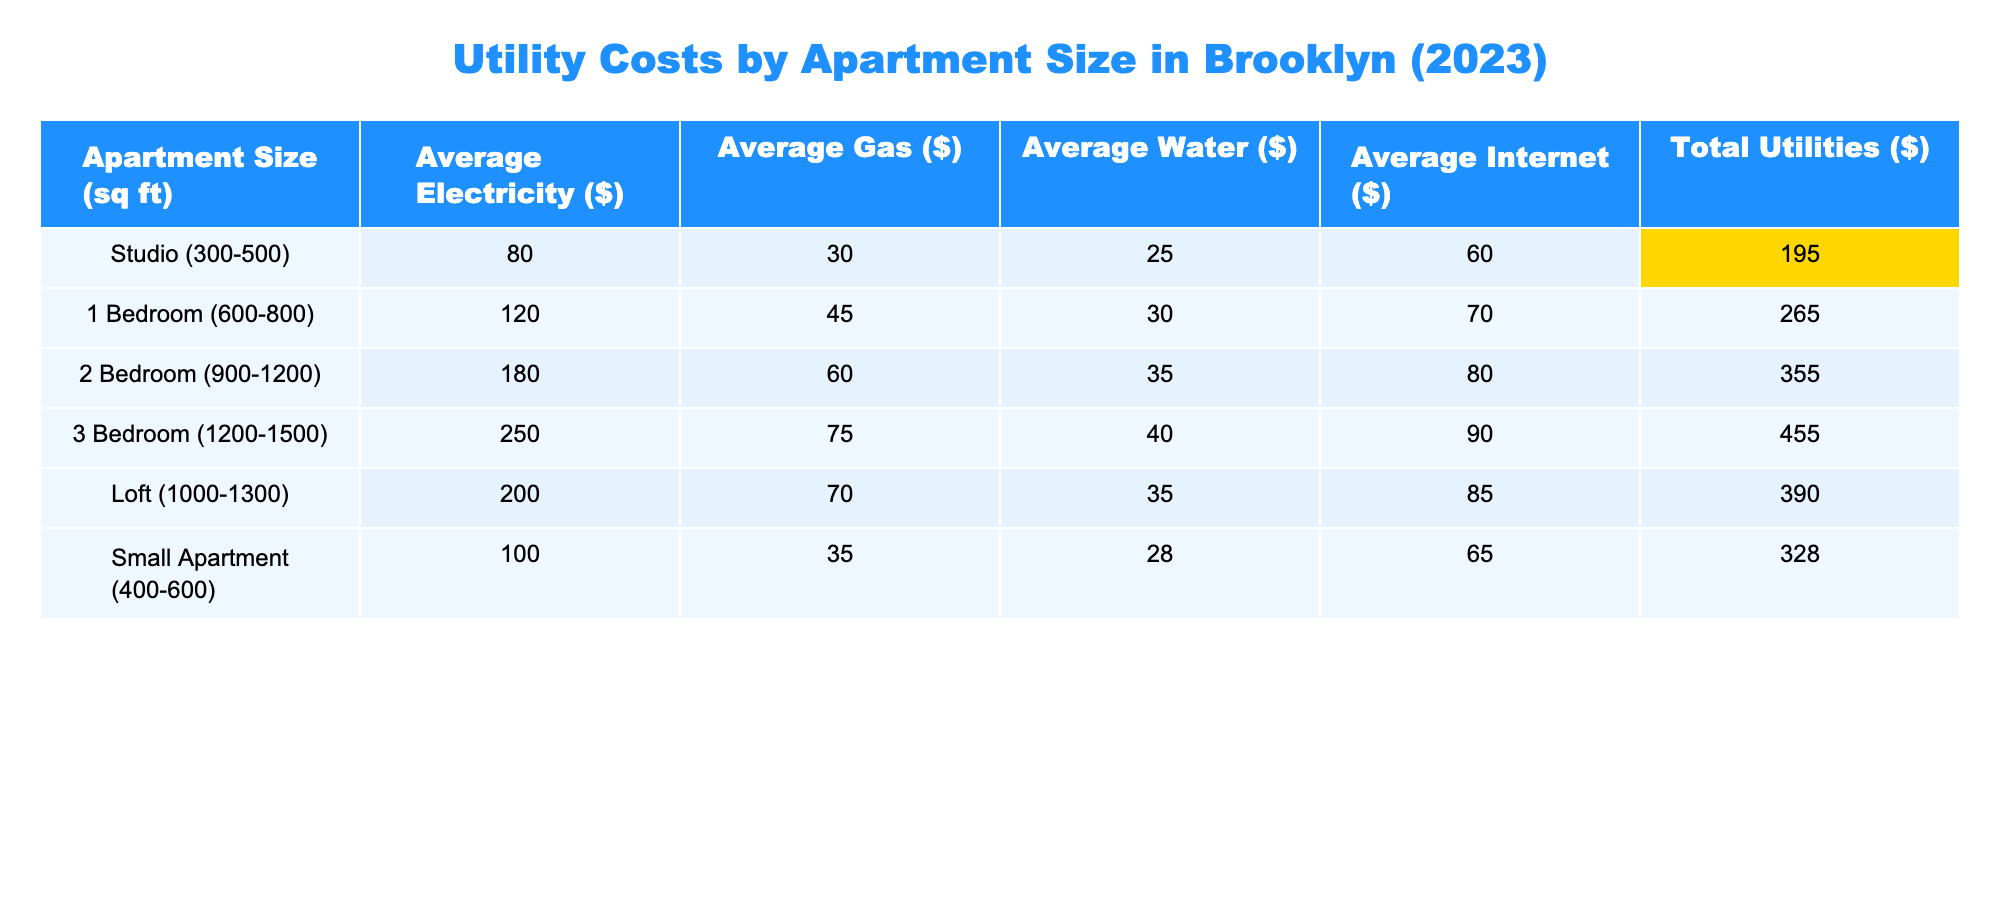What's the total utility cost for a studio apartment? The table shows the total utilities cost for a studio apartment as $195.
Answer: 195 Which apartment size has the highest average electricity cost? The 3 Bedroom apartment has the highest average electricity cost of $250.
Answer: 3 Bedroom What is the average total utilities cost for a 1 Bedroom apartment? According to the table, the average total utilities cost for a 1 Bedroom apartment is $265.
Answer: 265 Is the average internet cost for a Loft apartment greater than that for a Studio apartment? The average internet cost for a Loft apartment is $85, while for a Studio apartment, it is $60. Since $85 is greater than $60, the statement is true.
Answer: Yes What is the difference in total utilities cost between a 2 Bedroom and a 3 Bedroom apartment? The total utilities cost for a 2 Bedroom apartment is $355, and for a 3 Bedroom, it is $455. The difference is $455 - $355 = $100.
Answer: 100 What is the average gas cost for all apartment sizes? The gas costs across apartment sizes are: 30, 45, 60, 75, 70, and 35. The sum is 30 + 45 + 60 + 75 + 70 + 35 = 315. There are 6 data points, so the average is 315 / 6 = 52.5.
Answer: 52.5 Do lofts have lower average water costs than 1 Bedroom apartments? The average water cost for Loft apartments is $35, and for 1 Bedroom apartments, it is $30. Since $35 is not lower than $30, the answer is false.
Answer: No Which apartment size has the lowest total utilities cost and what is that cost? The table highlights that the Studio apartment has the lowest total utilities cost of $195.
Answer: 195 If I combine the total utilities costs of a Small Apartment and a Loft, what will be the total? The total utilities cost for a Small Apartment is $328, and for a Loft, it is $390. Adding these gives $328 + $390 = $718.
Answer: 718 Is the average water cost for a Studio apartment greater than the average for a Loft? The average water cost for the Studio apartment is $25, and for the Loft, it is $35. Since $25 is not greater than $35, the statement is false.
Answer: No 